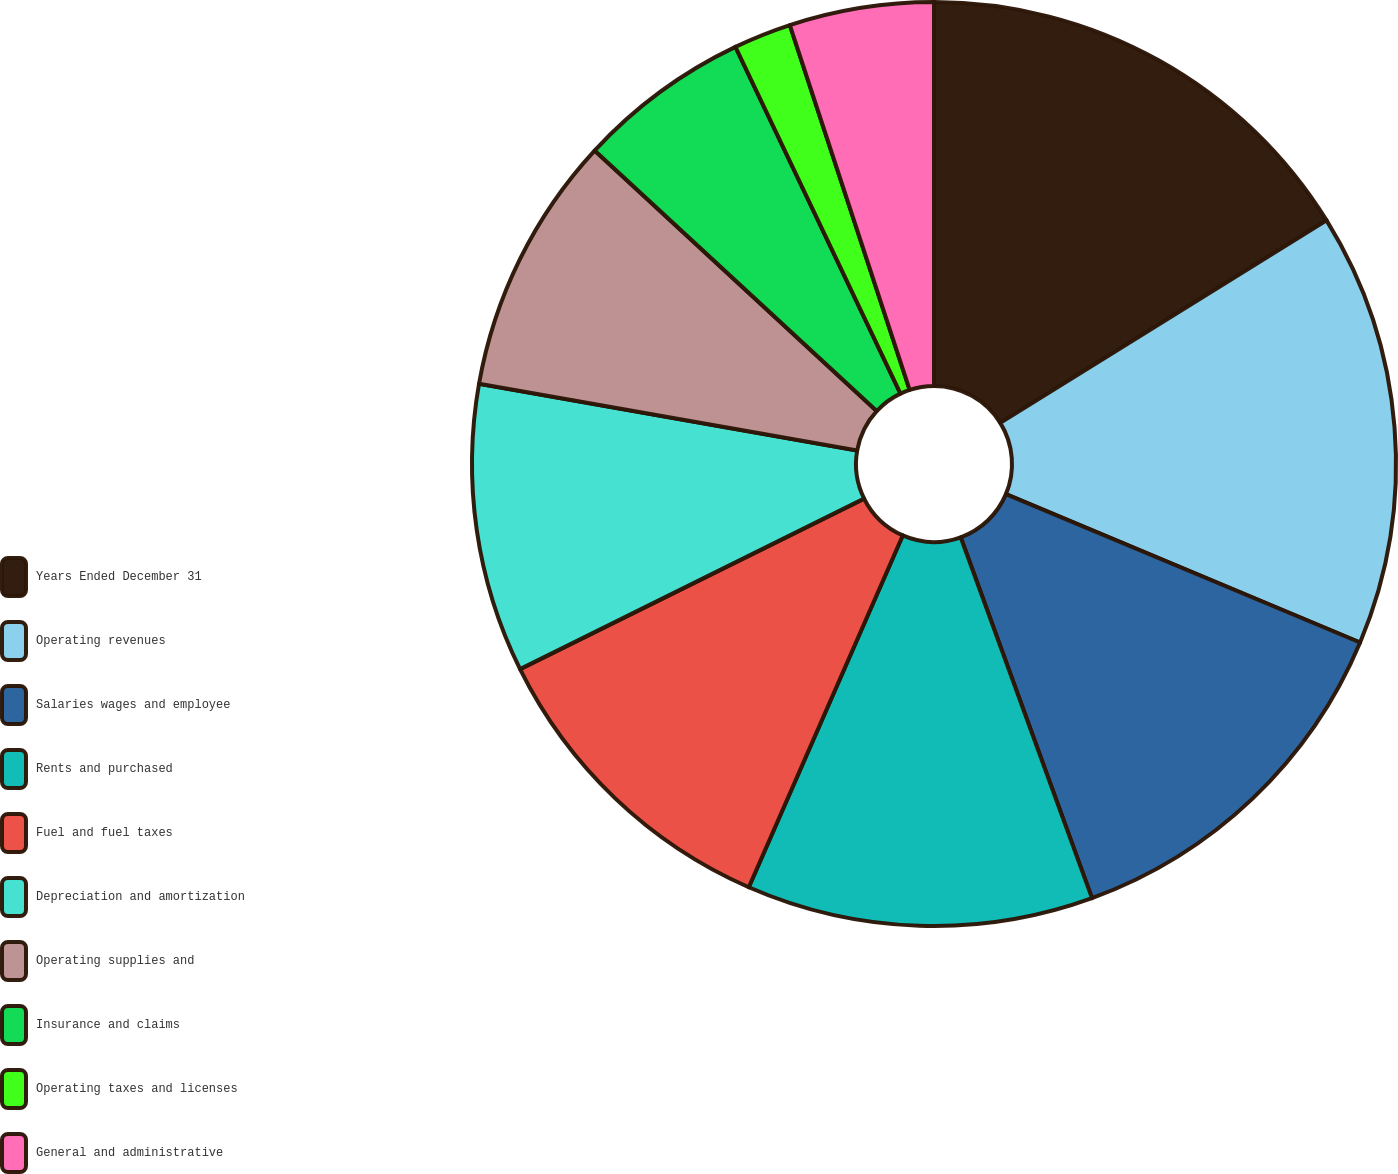Convert chart. <chart><loc_0><loc_0><loc_500><loc_500><pie_chart><fcel>Years Ended December 31<fcel>Operating revenues<fcel>Salaries wages and employee<fcel>Rents and purchased<fcel>Fuel and fuel taxes<fcel>Depreciation and amortization<fcel>Operating supplies and<fcel>Insurance and claims<fcel>Operating taxes and licenses<fcel>General and administrative<nl><fcel>16.16%<fcel>15.15%<fcel>13.13%<fcel>12.12%<fcel>11.11%<fcel>10.1%<fcel>9.09%<fcel>6.06%<fcel>2.02%<fcel>5.05%<nl></chart> 